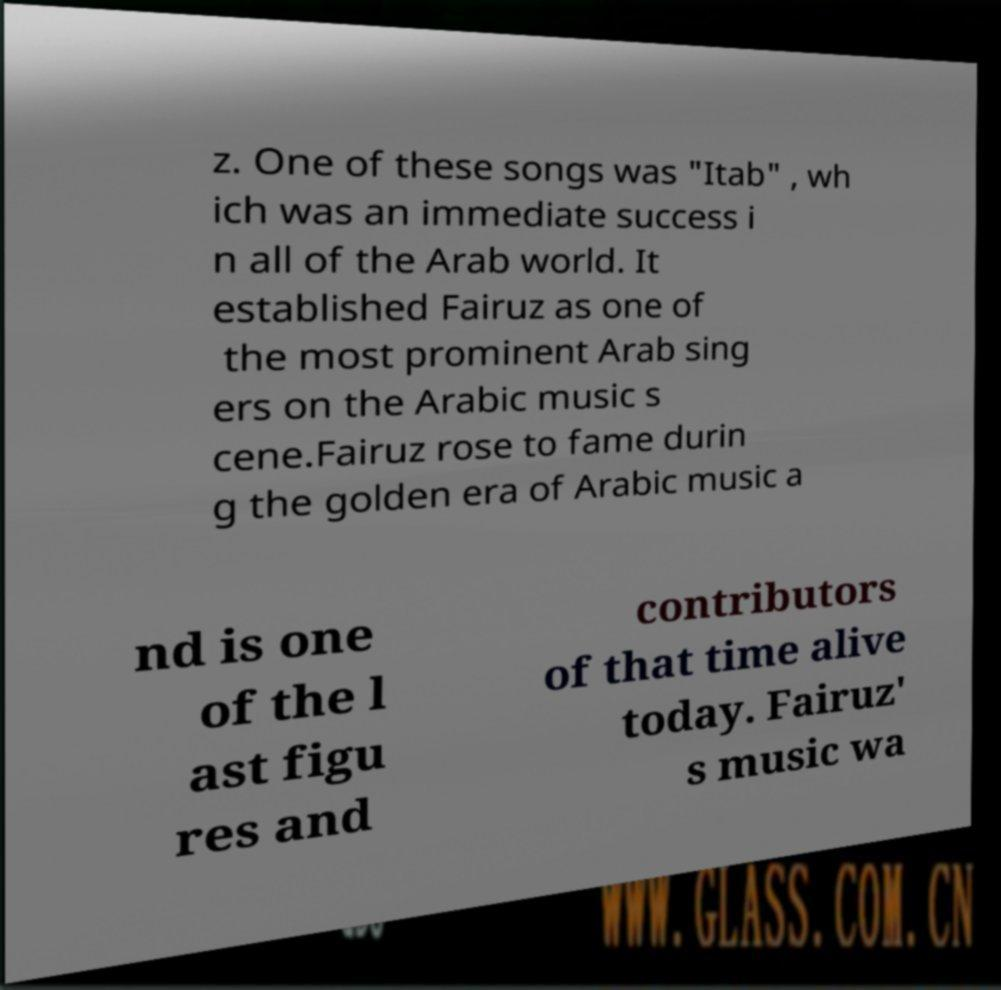Please read and relay the text visible in this image. What does it say? z. One of these songs was "Itab" , wh ich was an immediate success i n all of the Arab world. It established Fairuz as one of the most prominent Arab sing ers on the Arabic music s cene.Fairuz rose to fame durin g the golden era of Arabic music a nd is one of the l ast figu res and contributors of that time alive today. Fairuz' s music wa 